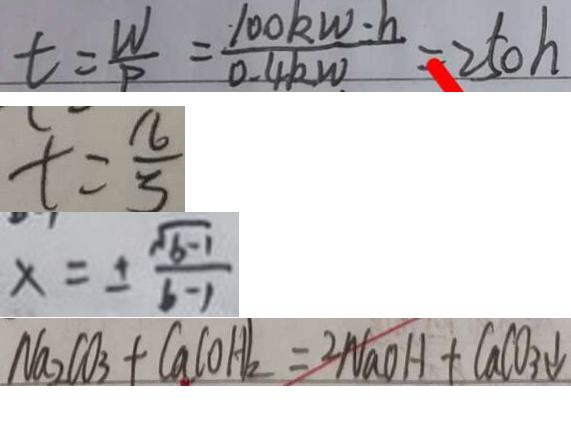Convert formula to latex. <formula><loc_0><loc_0><loc_500><loc_500>t = \frac { W } { P } = \frac { 1 0 0 k w \cdot h } { 0 . 4 k W } = 2 5 0 h 
 t = \frac { 1 6 } { 5 } 
 x = \pm \frac { \sqrt { b - 1 } } { b - 1 } 
 N a _ { 2 } C O _ { 3 } + C a ( O H ) _ { 2 } = 2 N a O H + C a C O _ { 3 } \downarrow</formula> 